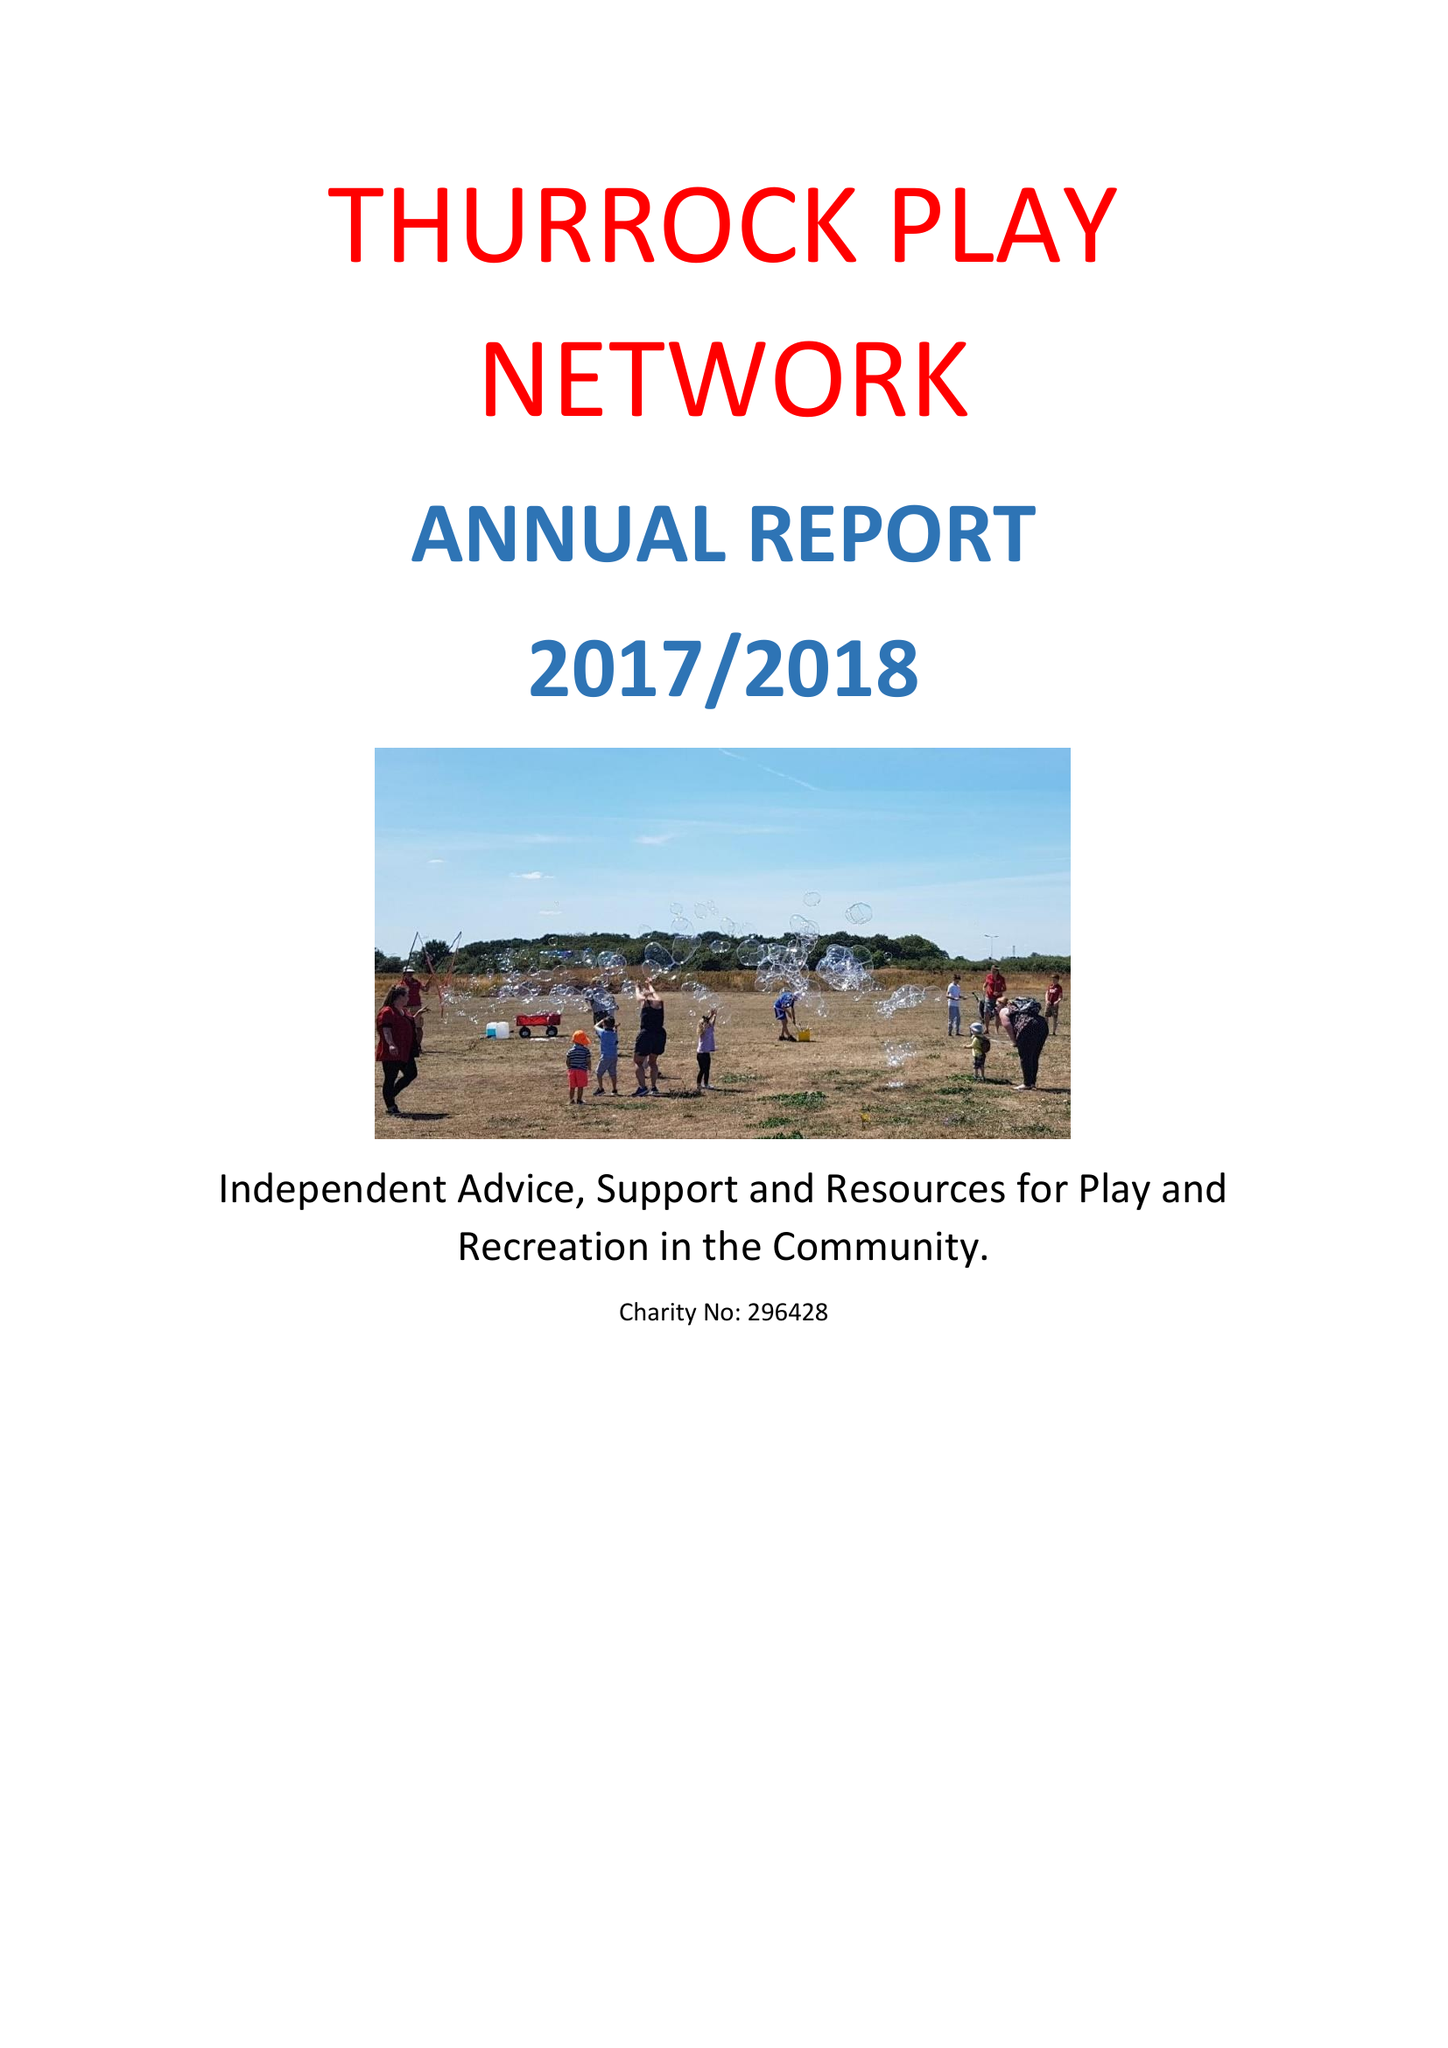What is the value for the address__post_town?
Answer the question using a single word or phrase. GRAYS 